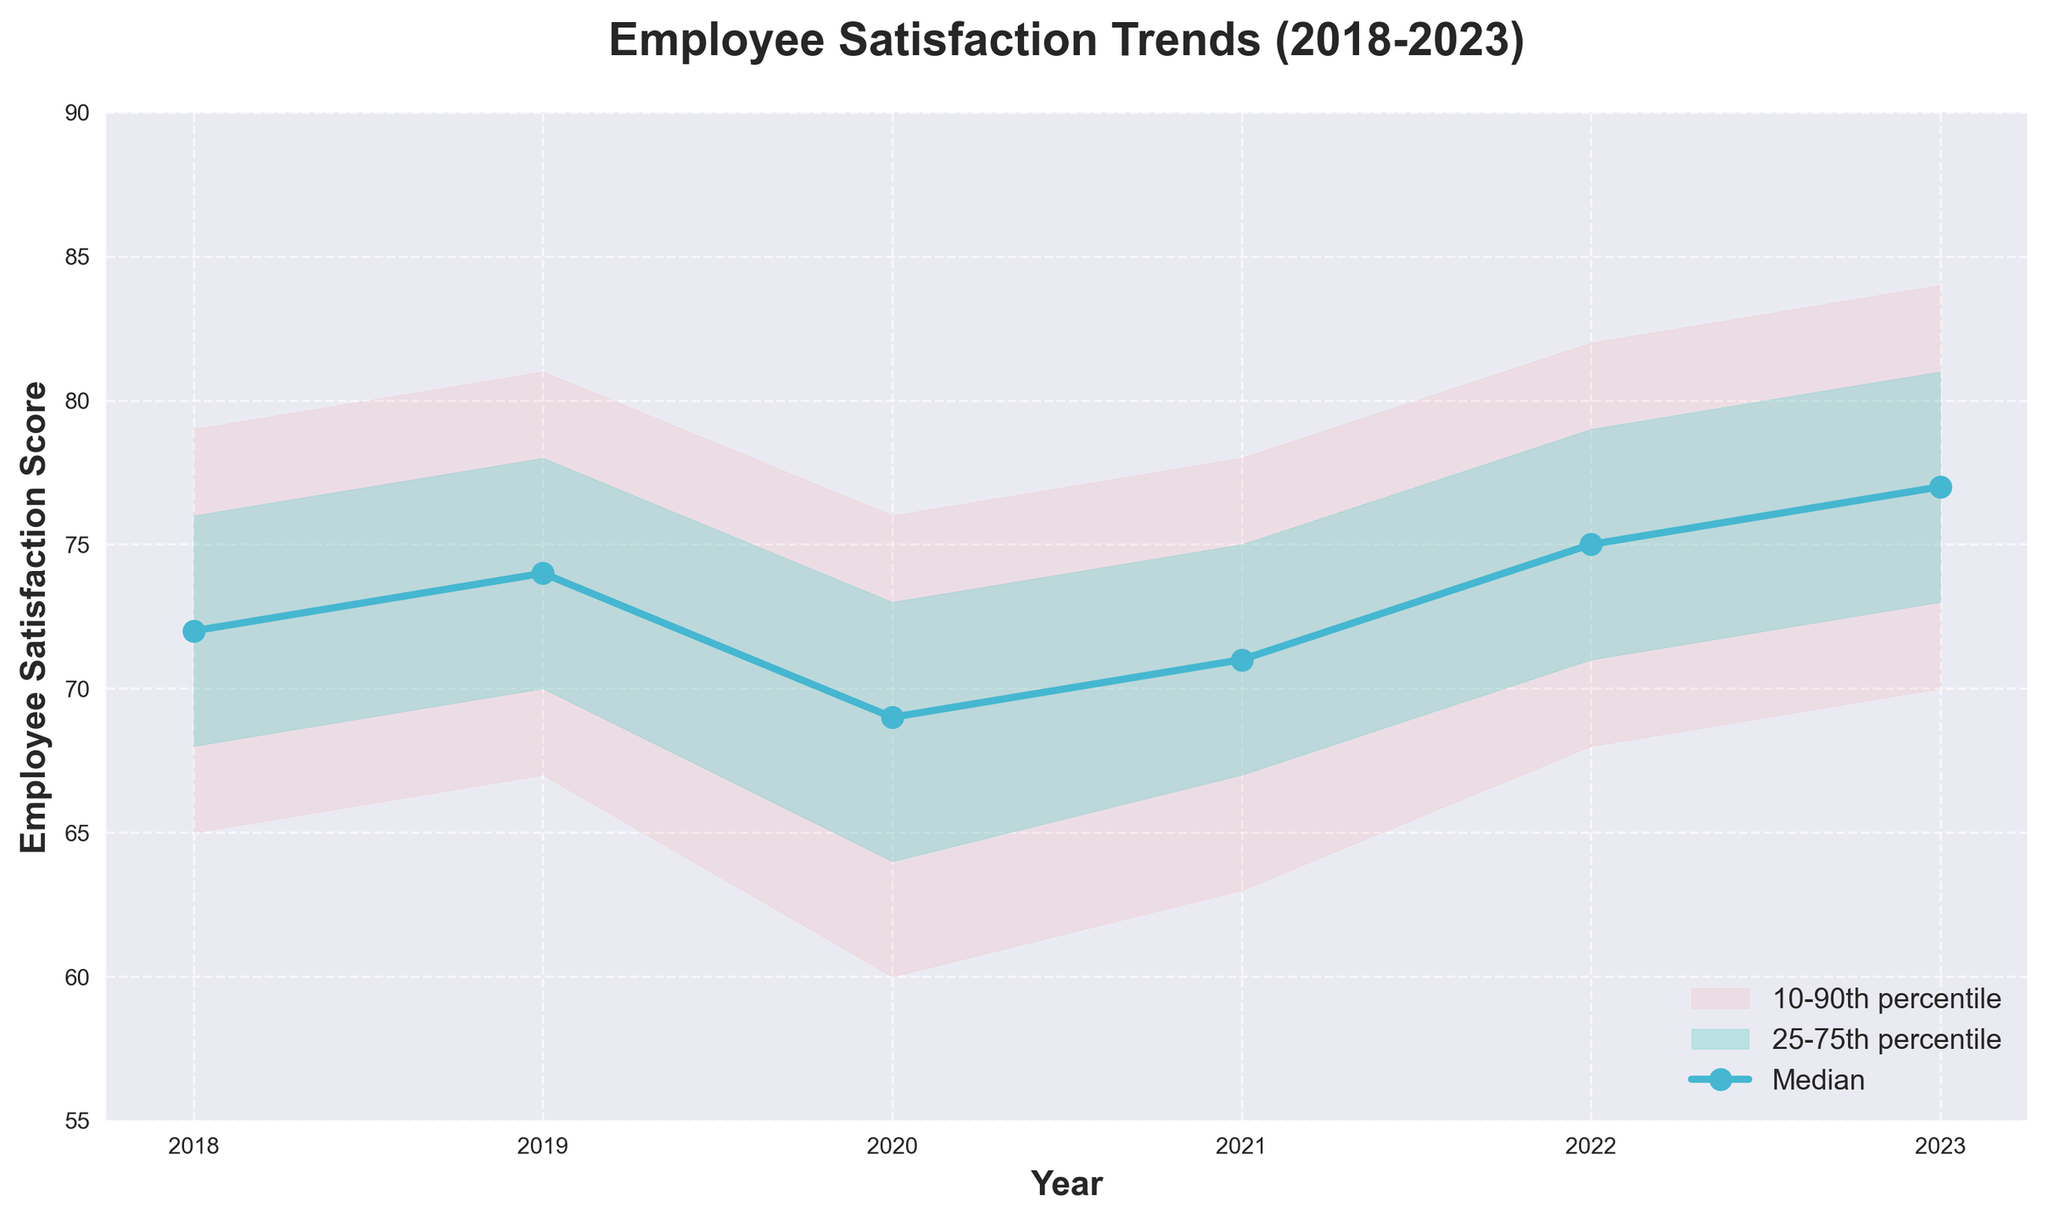What is the title of the figure? The title of the figure is displayed at the top of the chart. It reads, "Employee Satisfaction Trends (2018-2023)".
Answer: Employee Satisfaction Trends (2018-2023) Between which years does the dataset range? The x-axis of the chart shows years from 2018 to 2023.
Answer: 2018 to 2023 What color represents the median employee satisfaction score? The median employee satisfaction score is represented by a blue line with markers.
Answer: Blue What is the trend of the median employee satisfaction score from 2018 to 2023? The median starts at 72 in 2018, fluctuates a bit, but generally increases, ending at 77 in 2023.
Answer: Increasing What were the minimum and maximum values of the median employee satisfaction score over the period? The minimum median score was 69 in 2020, and the maximum median score was 77 in 2023.
Answer: 69 and 77 What is the range of employee satisfaction scores for the year 2020, based on the 10th and 90th percentiles? The 10th percentile for 2020 is 60 and the 90th percentile is 76. So, the range is 60 to 76.
Answer: 60 to 76 How did the satisfaction score distribution change from 2020 to 2023? From 2020 to 2023, the median increased from 69 to 77, and the spread between the 10th and 90th percentiles also increased, indicating more variability.
Answer: More variability and increased median What years saw a median employee satisfaction score above 72? The years with a median employee satisfaction score above 72 are 2019, 2022, and 2023.
Answer: 2019, 2022, 2023 Which percentile bands are represented by red and green shades and what do they signify? The red shade represents the 10-90th percentile band, and the green shade represents the 25-75th percentile band. These indicate the spread in the dataset with varying levels of confidence.
Answer: 10-90th percentile (red), 25-75th percentile (green) 